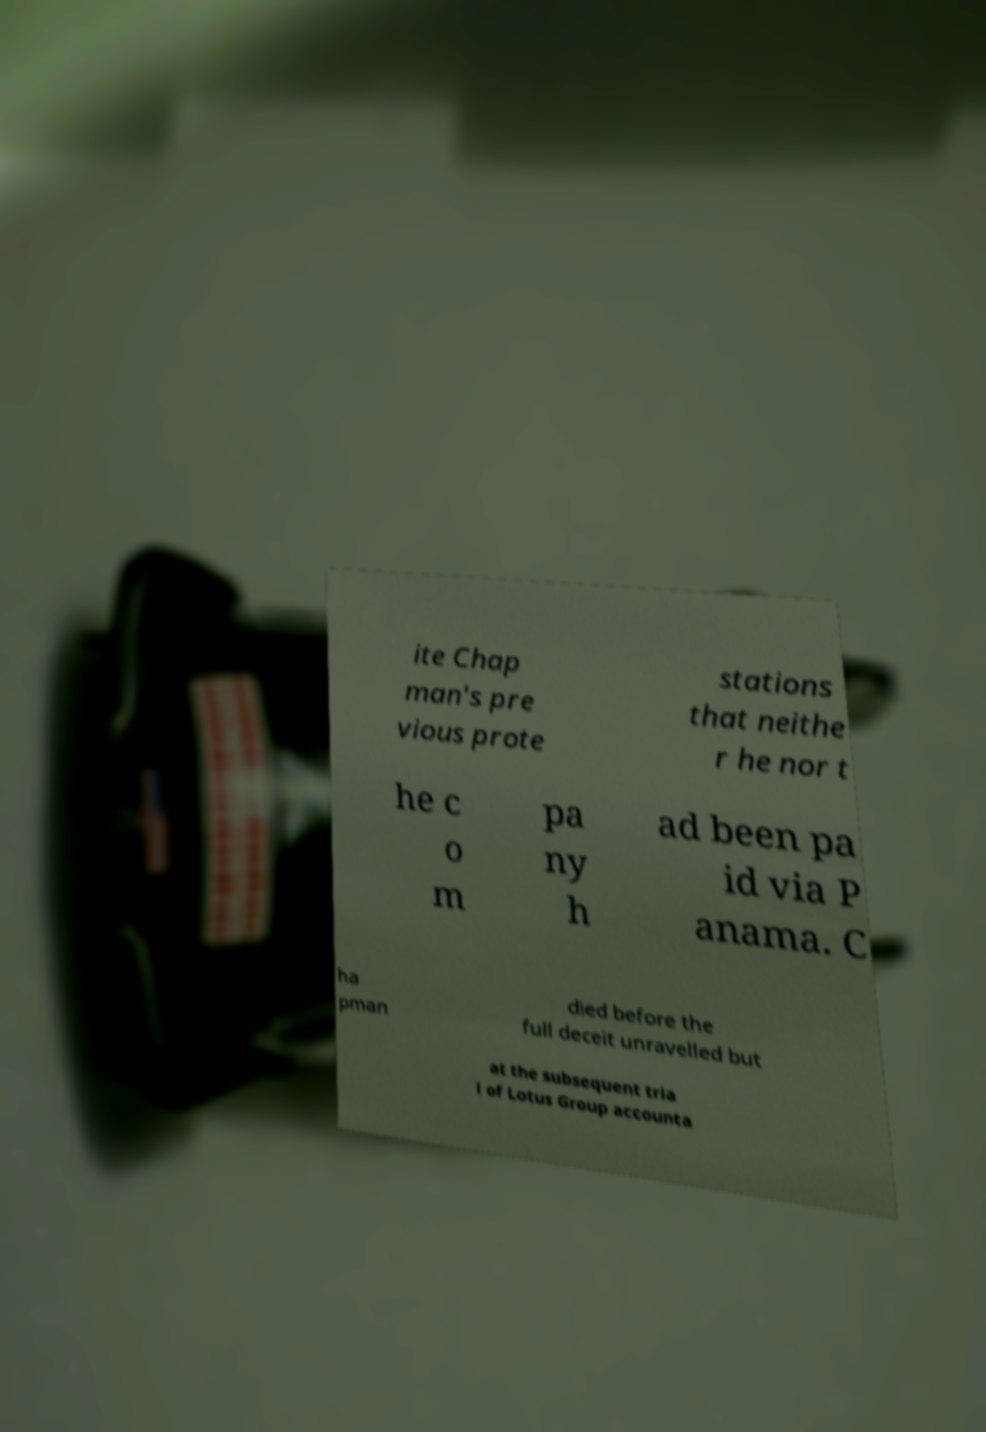What messages or text are displayed in this image? I need them in a readable, typed format. ite Chap man's pre vious prote stations that neithe r he nor t he c o m pa ny h ad been pa id via P anama. C ha pman died before the full deceit unravelled but at the subsequent tria l of Lotus Group accounta 